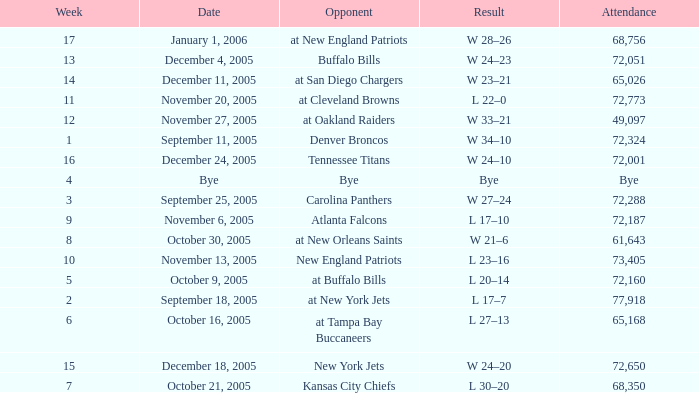Help me parse the entirety of this table. {'header': ['Week', 'Date', 'Opponent', 'Result', 'Attendance'], 'rows': [['17', 'January 1, 2006', 'at New England Patriots', 'W 28–26', '68,756'], ['13', 'December 4, 2005', 'Buffalo Bills', 'W 24–23', '72,051'], ['14', 'December 11, 2005', 'at San Diego Chargers', 'W 23–21', '65,026'], ['11', 'November 20, 2005', 'at Cleveland Browns', 'L 22–0', '72,773'], ['12', 'November 27, 2005', 'at Oakland Raiders', 'W 33–21', '49,097'], ['1', 'September 11, 2005', 'Denver Broncos', 'W 34–10', '72,324'], ['16', 'December 24, 2005', 'Tennessee Titans', 'W 24–10', '72,001'], ['4', 'Bye', 'Bye', 'Bye', 'Bye'], ['3', 'September 25, 2005', 'Carolina Panthers', 'W 27–24', '72,288'], ['9', 'November 6, 2005', 'Atlanta Falcons', 'L 17–10', '72,187'], ['8', 'October 30, 2005', 'at New Orleans Saints', 'W 21–6', '61,643'], ['10', 'November 13, 2005', 'New England Patriots', 'L 23–16', '73,405'], ['5', 'October 9, 2005', 'at Buffalo Bills', 'L 20–14', '72,160'], ['2', 'September 18, 2005', 'at New York Jets', 'L 17–7', '77,918'], ['6', 'October 16, 2005', 'at Tampa Bay Buccaneers', 'L 27–13', '65,168'], ['15', 'December 18, 2005', 'New York Jets', 'W 24–20', '72,650'], ['7', 'October 21, 2005', 'Kansas City Chiefs', 'L 30–20', '68,350']]} What is the Date of the game with an attendance of 72,051 after Week 9? December 4, 2005. 